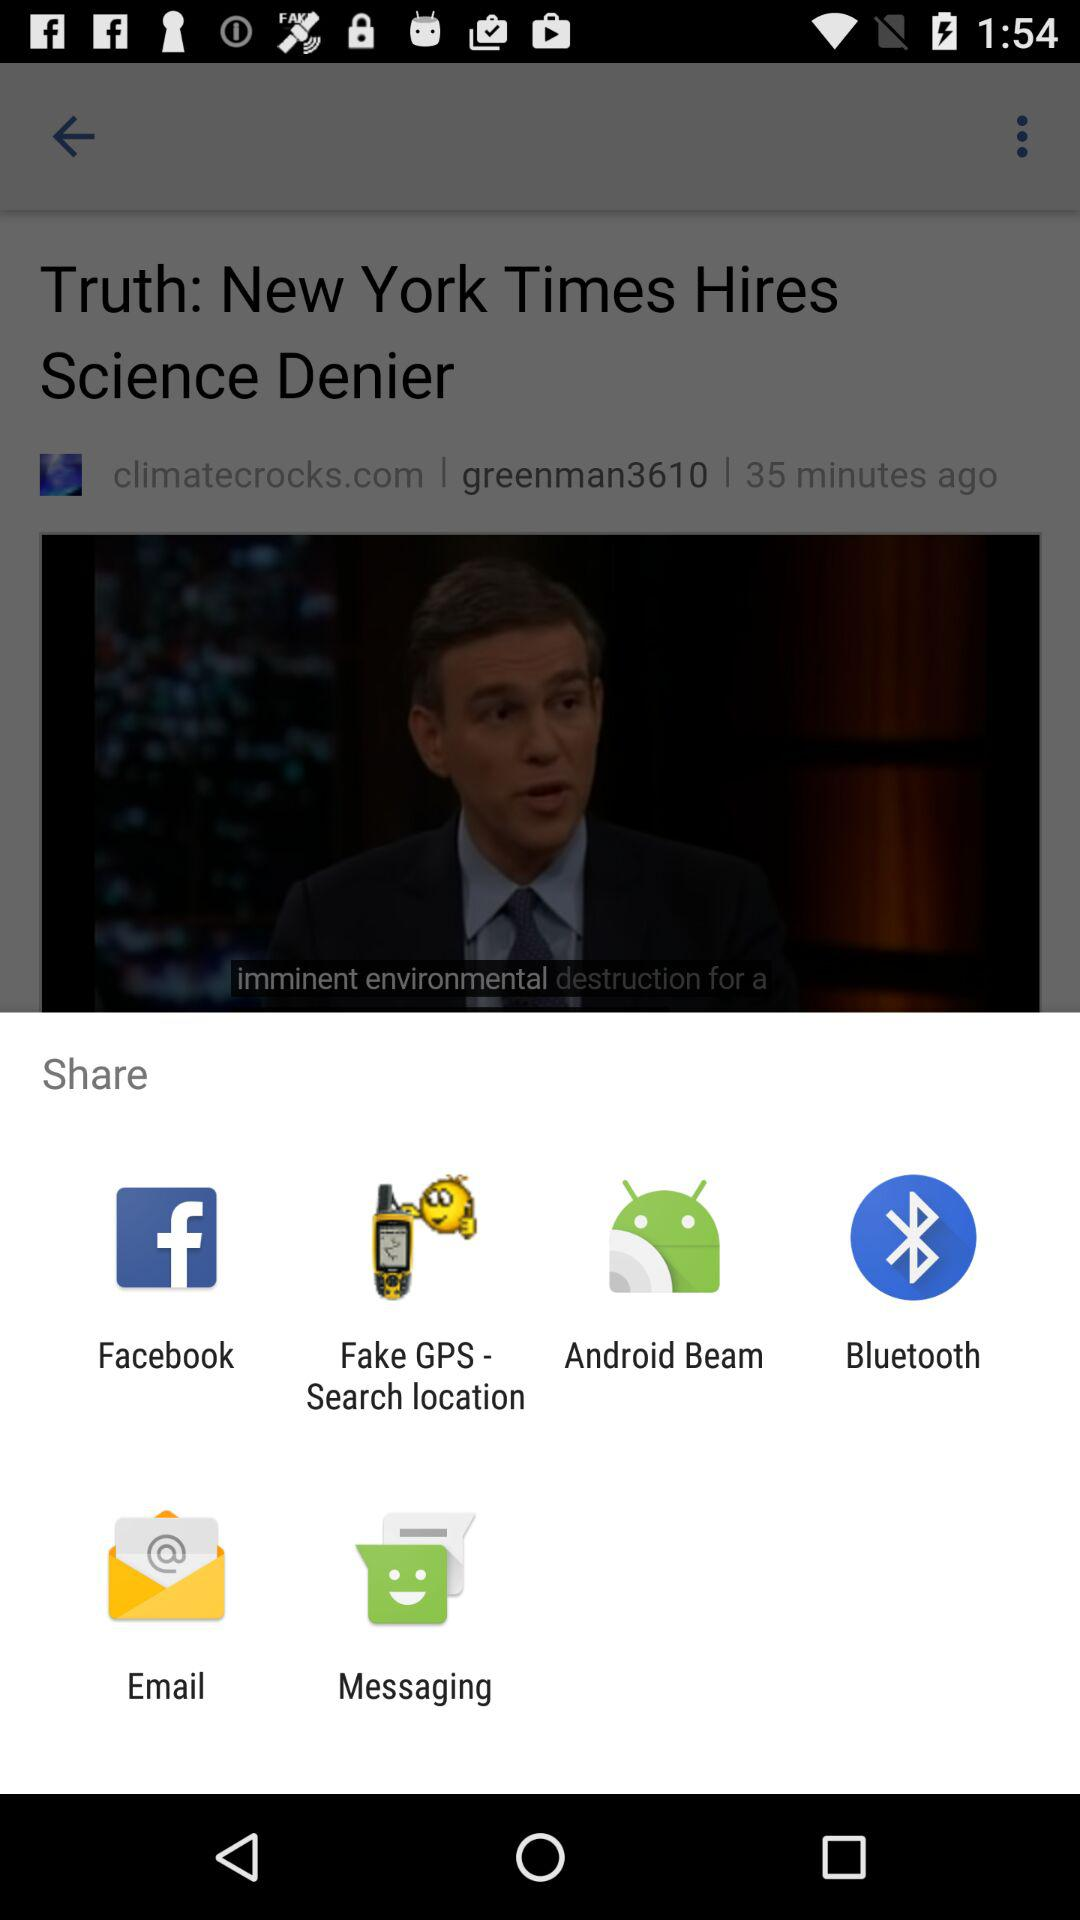What are the options we can share through? We can share through "Facebook", "Fake GPS - Search location", "Android Beam", "Bluetooth", "Email", and "Messaging". 